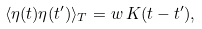<formula> <loc_0><loc_0><loc_500><loc_500>\langle \eta ( t ) \eta ( t ^ { \prime } ) \rangle _ { T } = w \, K ( t - t ^ { \prime } ) ,</formula> 